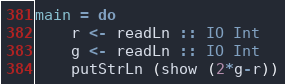Convert code to text. <code><loc_0><loc_0><loc_500><loc_500><_Haskell_>main = do
    r <- readLn :: IO Int
    g <- readLn :: IO Int
    putStrLn (show (2*g-r))</code> 